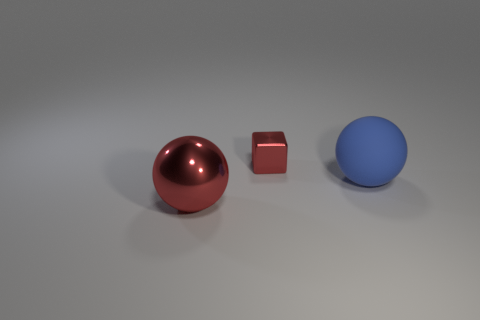Is there a tiny cyan ball?
Ensure brevity in your answer.  No. How many other objects are there of the same size as the red cube?
Make the answer very short. 0. There is a block; does it have the same color as the ball that is on the right side of the large red sphere?
Ensure brevity in your answer.  No. What number of things are big red objects or large rubber balls?
Provide a short and direct response. 2. Is there any other thing that has the same color as the small object?
Give a very brief answer. Yes. Do the tiny red cube and the large ball that is to the left of the rubber thing have the same material?
Your response must be concise. Yes. There is a red thing to the left of the metallic thing that is behind the big rubber sphere; what is its shape?
Offer a very short reply. Sphere. There is a thing that is right of the metallic sphere and left of the blue rubber ball; what is its shape?
Your answer should be very brief. Cube. What number of objects are tiny blue shiny cubes or large things behind the big metallic thing?
Your answer should be compact. 1. There is another large thing that is the same shape as the big metallic thing; what is its material?
Your answer should be compact. Rubber. 